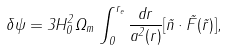Convert formula to latex. <formula><loc_0><loc_0><loc_500><loc_500>\delta \psi = 3 H _ { 0 } ^ { 2 } \Omega _ { m } \, \int _ { 0 } ^ { r _ { e } } \frac { d r } { a ^ { 2 } ( r ) } [ \vec { n } \cdot \vec { F } ( \vec { r } ) ] ,</formula> 